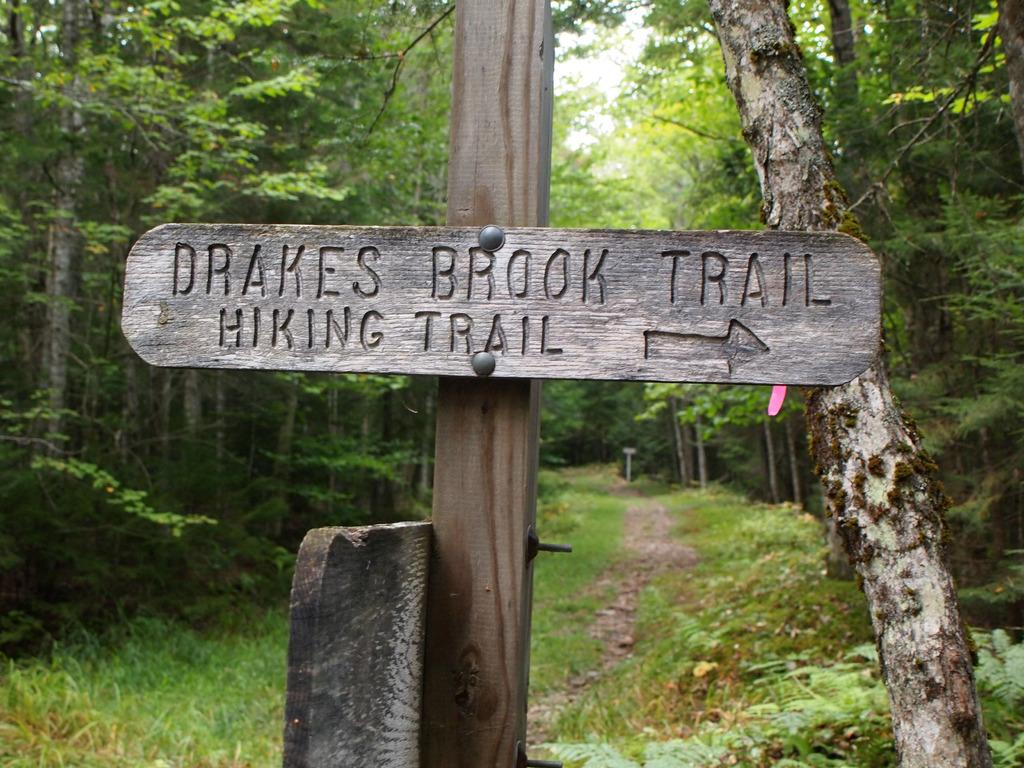What object is present in the image that has a name on it? There is a wooden name plate in the image. How is the name plate positioned in the image? The name plate is attached to a wooden pole. What can be seen in the background of the image? A: There are trees in the background of the image. What type of fowl can be seen perched on the name plate in the image? There are no fowl present on the name plate or in the image. 